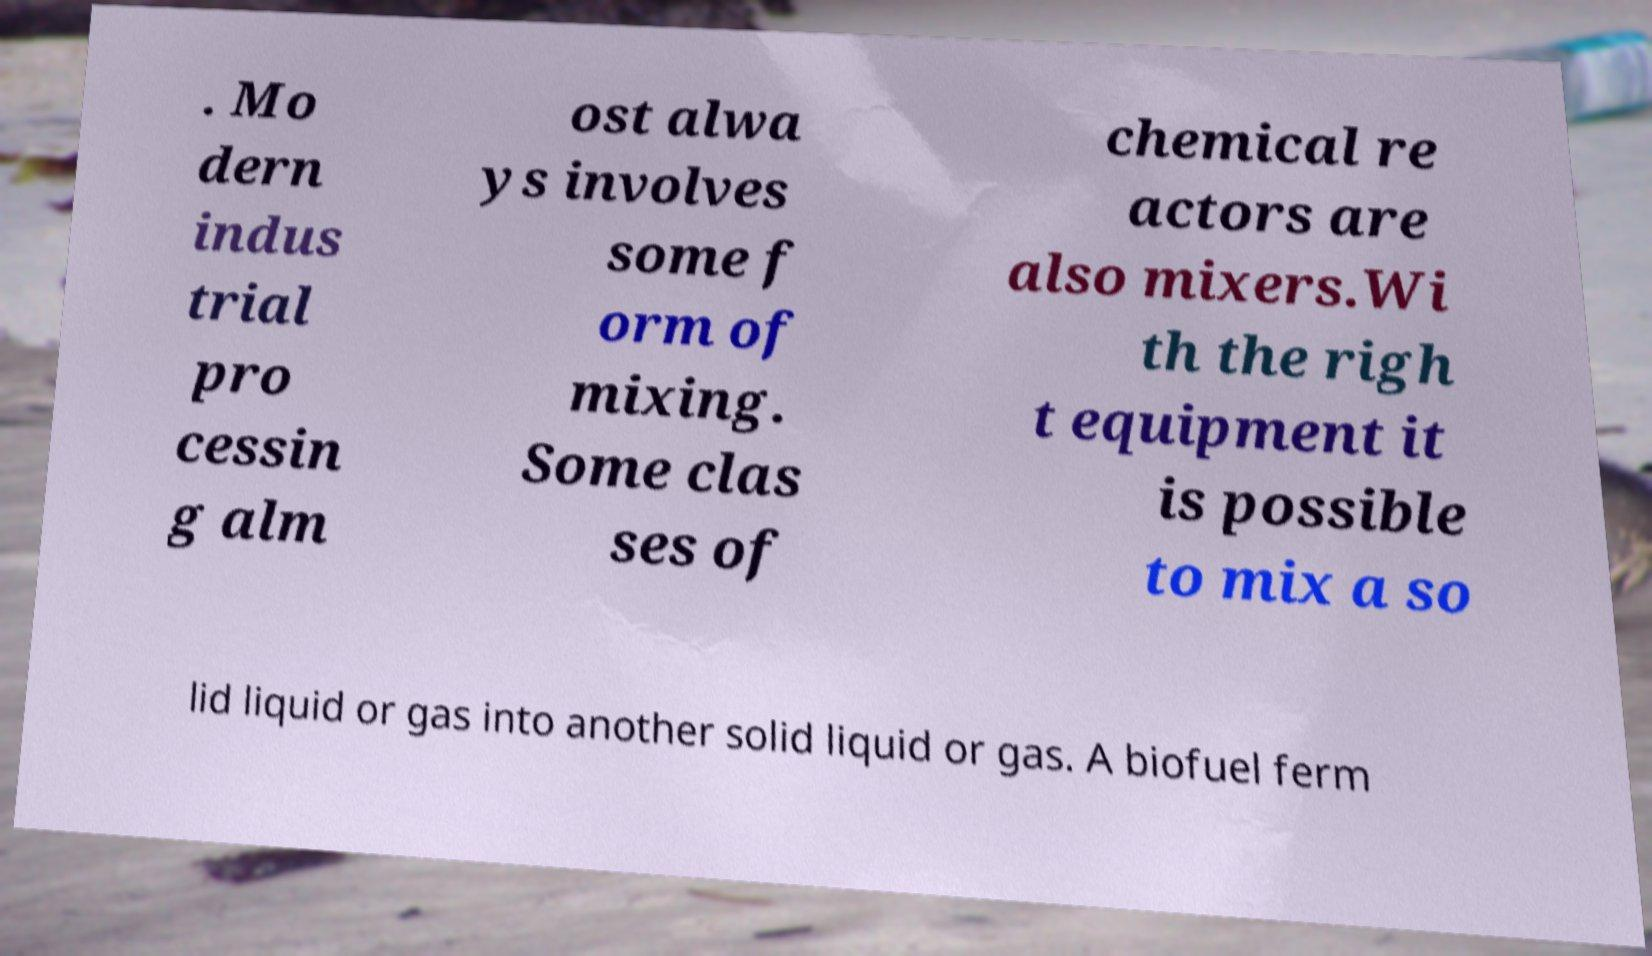Could you extract and type out the text from this image? . Mo dern indus trial pro cessin g alm ost alwa ys involves some f orm of mixing. Some clas ses of chemical re actors are also mixers.Wi th the righ t equipment it is possible to mix a so lid liquid or gas into another solid liquid or gas. A biofuel ferm 